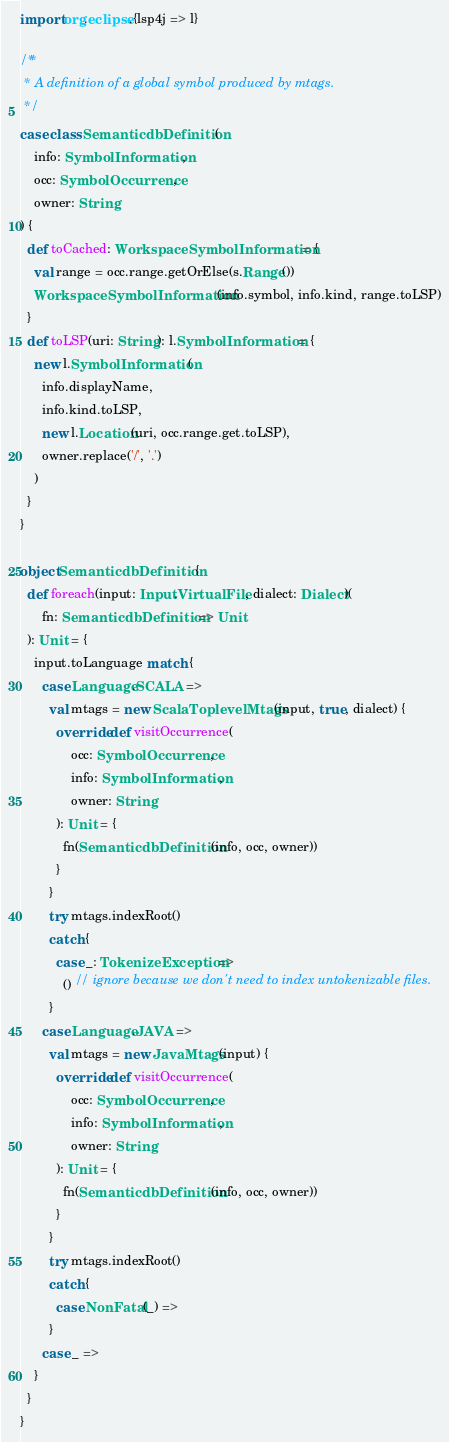Convert code to text. <code><loc_0><loc_0><loc_500><loc_500><_Scala_>
import org.eclipse.{lsp4j => l}

/**
 * A definition of a global symbol produced by mtags.
 */
case class SemanticdbDefinition(
    info: SymbolInformation,
    occ: SymbolOccurrence,
    owner: String
) {
  def toCached: WorkspaceSymbolInformation = {
    val range = occ.range.getOrElse(s.Range())
    WorkspaceSymbolInformation(info.symbol, info.kind, range.toLSP)
  }
  def toLSP(uri: String): l.SymbolInformation = {
    new l.SymbolInformation(
      info.displayName,
      info.kind.toLSP,
      new l.Location(uri, occ.range.get.toLSP),
      owner.replace('/', '.')
    )
  }
}

object SemanticdbDefinition {
  def foreach(input: Input.VirtualFile, dialect: Dialect)(
      fn: SemanticdbDefinition => Unit
  ): Unit = {
    input.toLanguage match {
      case Language.SCALA =>
        val mtags = new ScalaToplevelMtags(input, true, dialect) {
          override def visitOccurrence(
              occ: SymbolOccurrence,
              info: SymbolInformation,
              owner: String
          ): Unit = {
            fn(SemanticdbDefinition(info, occ, owner))
          }
        }
        try mtags.indexRoot()
        catch {
          case _: TokenizeException =>
            () // ignore because we don't need to index untokenizable files.
        }
      case Language.JAVA =>
        val mtags = new JavaMtags(input) {
          override def visitOccurrence(
              occ: SymbolOccurrence,
              info: SymbolInformation,
              owner: String
          ): Unit = {
            fn(SemanticdbDefinition(info, occ, owner))
          }
        }
        try mtags.indexRoot()
        catch {
          case NonFatal(_) =>
        }
      case _ =>
    }
  }
}
</code> 